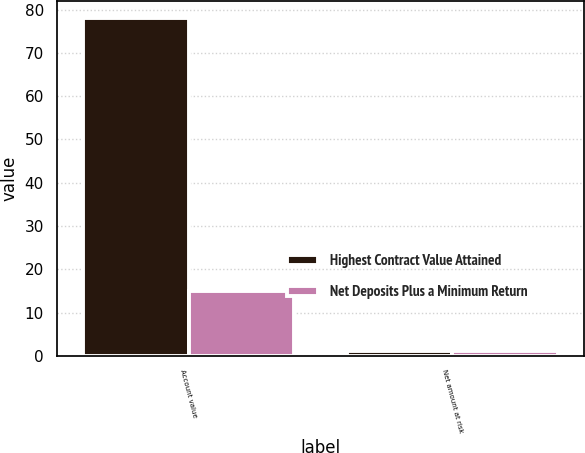<chart> <loc_0><loc_0><loc_500><loc_500><stacked_bar_chart><ecel><fcel>Account value<fcel>Net amount at risk<nl><fcel>Highest Contract Value Attained<fcel>78<fcel>1<nl><fcel>Net Deposits Plus a Minimum Return<fcel>15<fcel>1<nl></chart> 